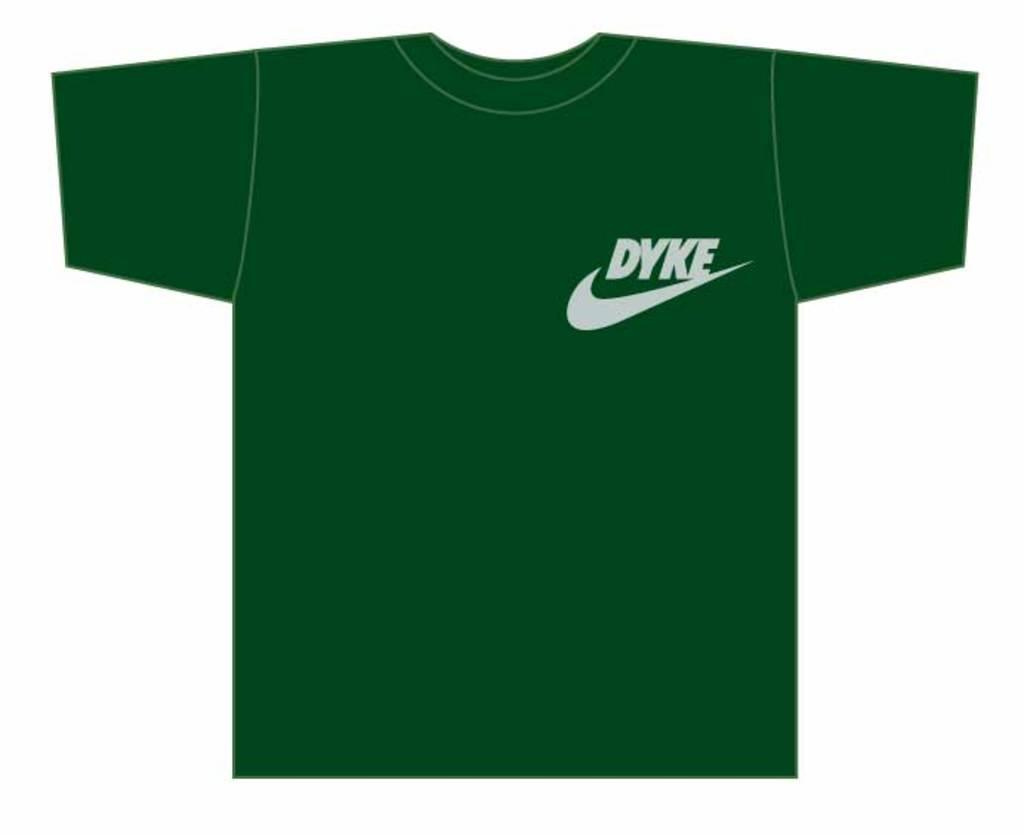What type of image is being described? The image is animated. What color is the t-shirt in the image? The t-shirt in the image is green. What text is written on the t-shirt? The text 'side' is written on the t-shirt in white color. Where is the text located on the t-shirt? The text is located at the right top of the t-shirt. What color is the background of the image? The background of the image is white. Is the brother of the person wearing the t-shirt also present in the image? There is no information about a brother or any other person in the image; it only features a green t-shirt with the text 'side' on it. Can you see a snake slithering in the background of the image? There is no snake present in the image; the background is white. 